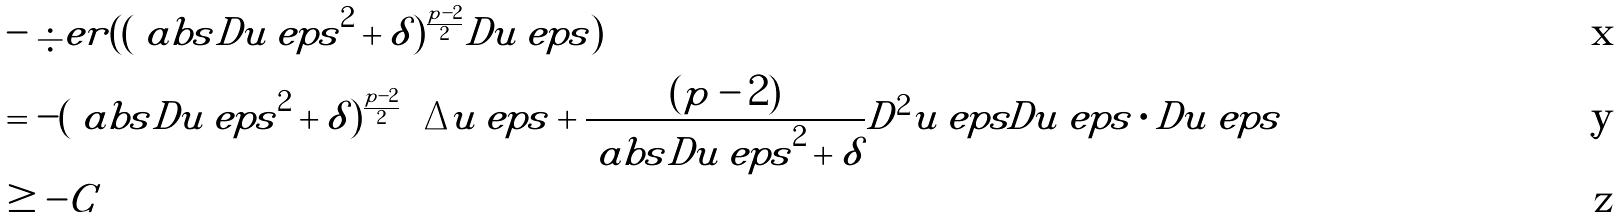Convert formula to latex. <formula><loc_0><loc_0><loc_500><loc_500>& - \div e r ( ( \ a b s { D u _ { \ } e p s } ^ { 2 } + \delta ) ^ { \frac { p - 2 } { 2 } } D u _ { \ } e p s ) \\ & = - ( \ a b s { D u _ { \ } e p s } ^ { 2 } + \delta ) ^ { \frac { p - 2 } { 2 } } \left ( \Delta u _ { \ } e p s + \frac { ( p - 2 ) } { \ a b s { D u _ { \ } e p s } ^ { 2 } + \delta } D ^ { 2 } u _ { \ } e p s D u _ { \ } e p s \cdot D u _ { \ } e p s \right ) \\ & \geq - C</formula> 